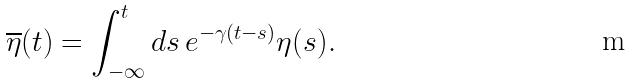Convert formula to latex. <formula><loc_0><loc_0><loc_500><loc_500>\overline { \eta } ( t ) = \int _ { - \infty } ^ { t } d s \, e ^ { - \gamma ( t - s ) } \eta ( s ) .</formula> 